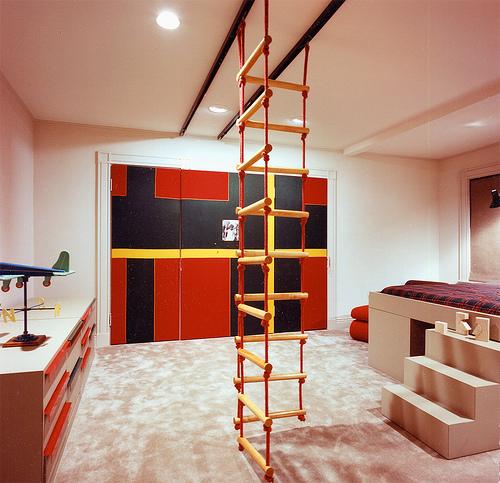How many rungs are in the ladder?
Quick response, please. 18. What room is this?
Keep it brief. Bedroom. Where is the ladder hanging?
Give a very brief answer. Ceiling. 